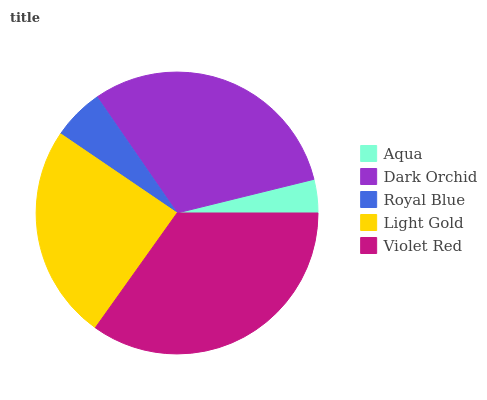Is Aqua the minimum?
Answer yes or no. Yes. Is Violet Red the maximum?
Answer yes or no. Yes. Is Dark Orchid the minimum?
Answer yes or no. No. Is Dark Orchid the maximum?
Answer yes or no. No. Is Dark Orchid greater than Aqua?
Answer yes or no. Yes. Is Aqua less than Dark Orchid?
Answer yes or no. Yes. Is Aqua greater than Dark Orchid?
Answer yes or no. No. Is Dark Orchid less than Aqua?
Answer yes or no. No. Is Light Gold the high median?
Answer yes or no. Yes. Is Light Gold the low median?
Answer yes or no. Yes. Is Dark Orchid the high median?
Answer yes or no. No. Is Royal Blue the low median?
Answer yes or no. No. 